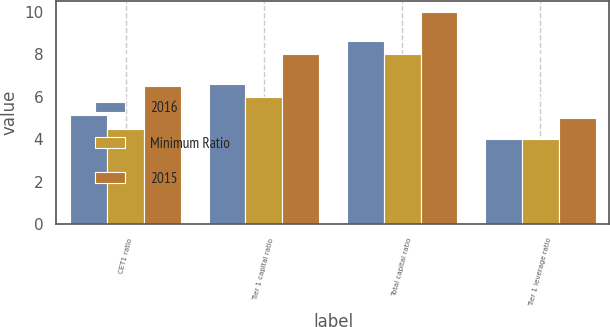<chart> <loc_0><loc_0><loc_500><loc_500><stacked_bar_chart><ecel><fcel>CET1 ratio<fcel>Tier 1 capital ratio<fcel>Total capital ratio<fcel>Tier 1 leverage ratio<nl><fcel>2016<fcel>5.12<fcel>6.62<fcel>8.62<fcel>4<nl><fcel>Minimum Ratio<fcel>4.5<fcel>6<fcel>8<fcel>4<nl><fcel>2015<fcel>6.5<fcel>8<fcel>10<fcel>5<nl></chart> 